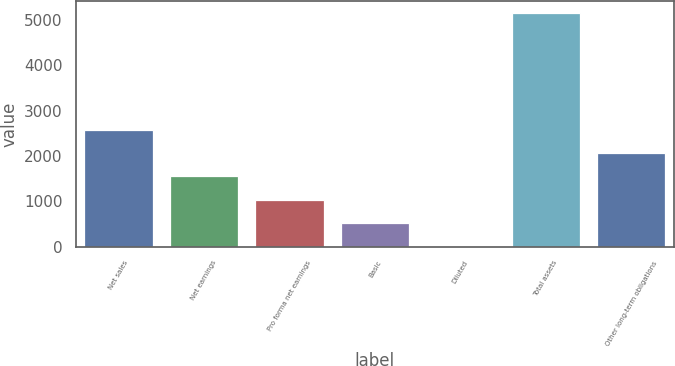Convert chart to OTSL. <chart><loc_0><loc_0><loc_500><loc_500><bar_chart><fcel>Net sales<fcel>Net earnings<fcel>Pro forma net earnings<fcel>Basic<fcel>Diluted<fcel>Total assets<fcel>Other long-term obligations<nl><fcel>2578.84<fcel>1547.96<fcel>1032.52<fcel>517.08<fcel>1.64<fcel>5156<fcel>2063.4<nl></chart> 